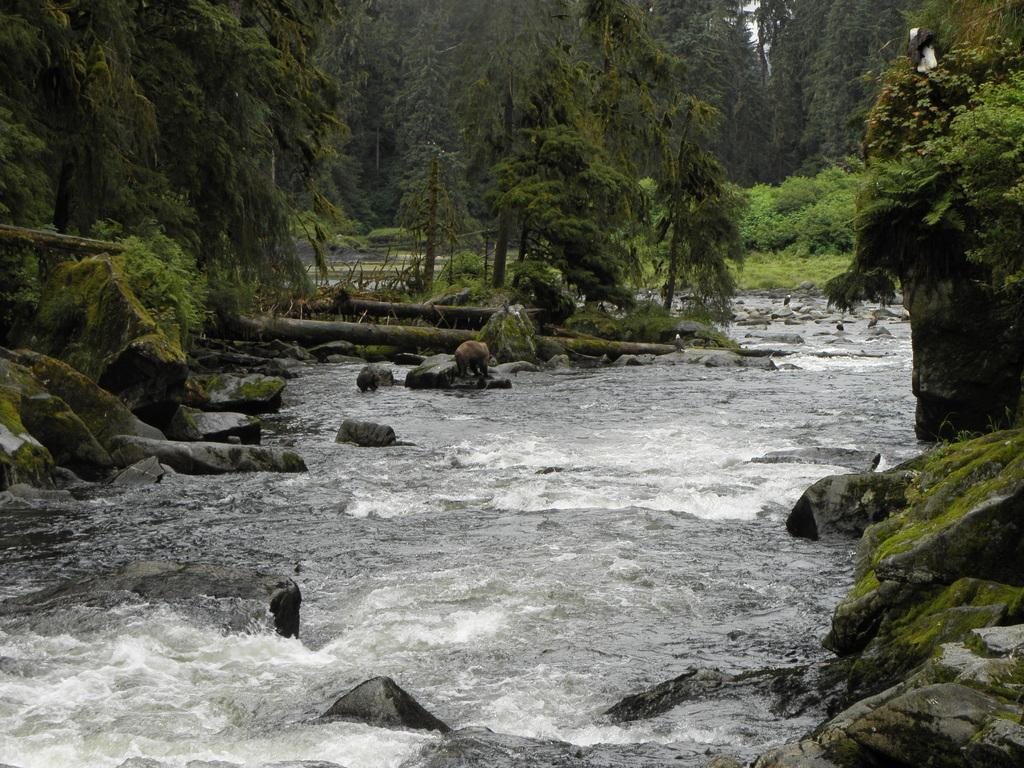What can be seen in the foreground area of the image? In the foreground area of the image, there are stones and water. What is visible in the background area of the image? In the background area of the image, there is greenery. Is there a car driving through the water in the image? No, there is no car or driving activity present in the image. Can you see a collar on any of the stones in the image? There are no collars visible on the stones in the image. 